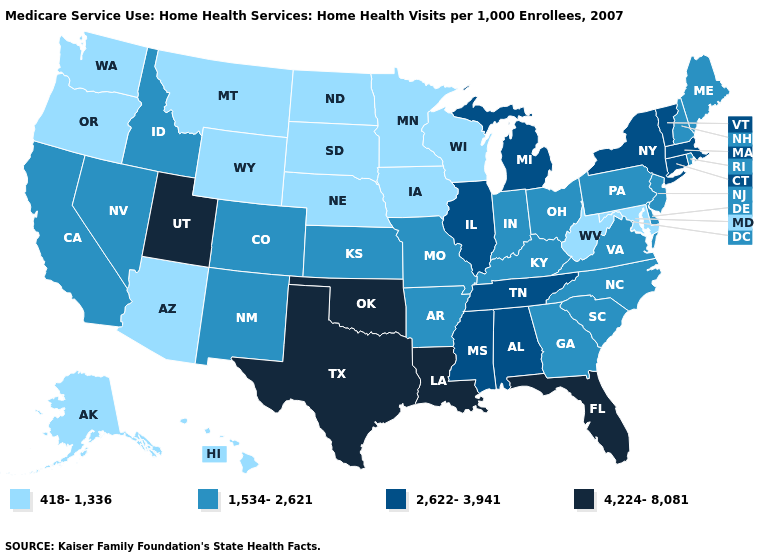What is the value of Idaho?
Answer briefly. 1,534-2,621. What is the value of New Mexico?
Quick response, please. 1,534-2,621. Is the legend a continuous bar?
Write a very short answer. No. Which states have the highest value in the USA?
Keep it brief. Florida, Louisiana, Oklahoma, Texas, Utah. Does Utah have the lowest value in the USA?
Keep it brief. No. What is the value of South Dakota?
Quick response, please. 418-1,336. Does Nebraska have the lowest value in the USA?
Give a very brief answer. Yes. What is the value of North Carolina?
Quick response, please. 1,534-2,621. What is the value of Nevada?
Answer briefly. 1,534-2,621. Name the states that have a value in the range 4,224-8,081?
Keep it brief. Florida, Louisiana, Oklahoma, Texas, Utah. Name the states that have a value in the range 1,534-2,621?
Concise answer only. Arkansas, California, Colorado, Delaware, Georgia, Idaho, Indiana, Kansas, Kentucky, Maine, Missouri, Nevada, New Hampshire, New Jersey, New Mexico, North Carolina, Ohio, Pennsylvania, Rhode Island, South Carolina, Virginia. Does the first symbol in the legend represent the smallest category?
Be succinct. Yes. Which states have the highest value in the USA?
Answer briefly. Florida, Louisiana, Oklahoma, Texas, Utah. What is the value of Iowa?
Keep it brief. 418-1,336. Name the states that have a value in the range 418-1,336?
Write a very short answer. Alaska, Arizona, Hawaii, Iowa, Maryland, Minnesota, Montana, Nebraska, North Dakota, Oregon, South Dakota, Washington, West Virginia, Wisconsin, Wyoming. 